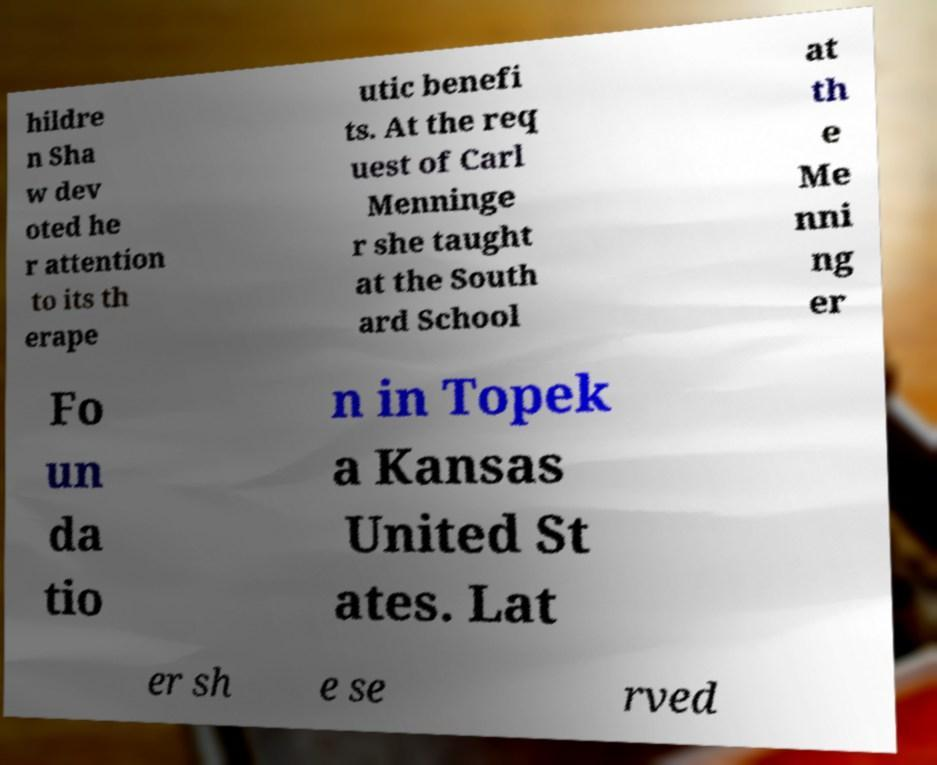Could you extract and type out the text from this image? hildre n Sha w dev oted he r attention to its th erape utic benefi ts. At the req uest of Carl Menninge r she taught at the South ard School at th e Me nni ng er Fo un da tio n in Topek a Kansas United St ates. Lat er sh e se rved 